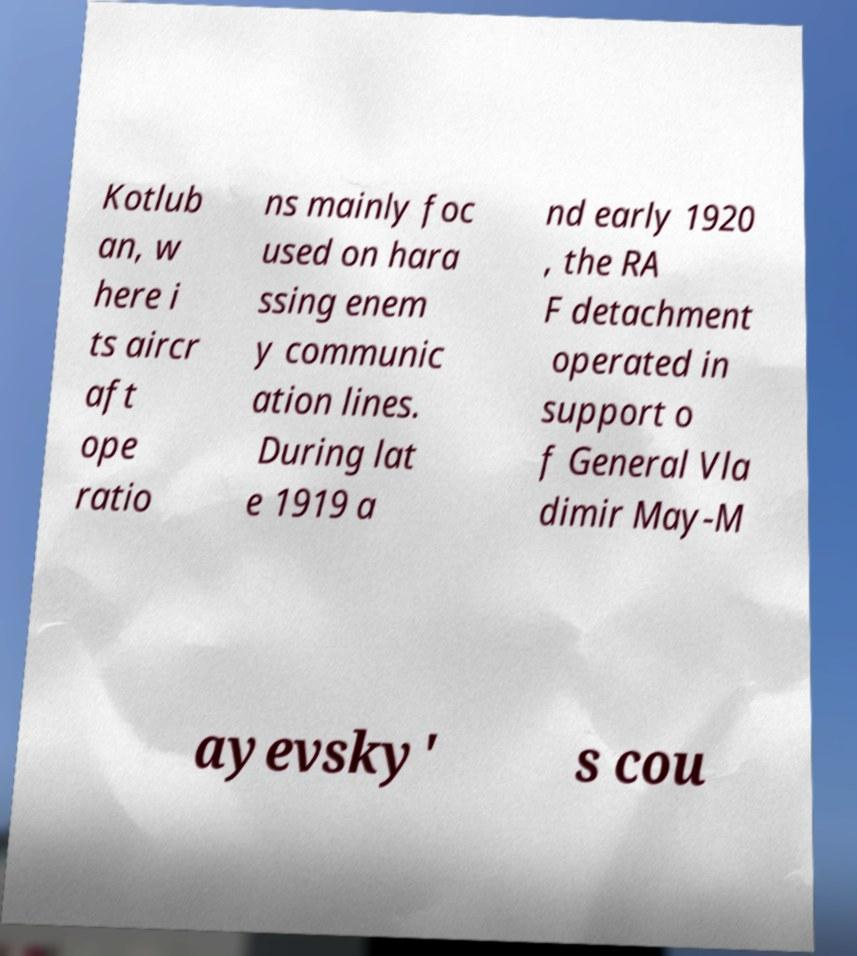Can you accurately transcribe the text from the provided image for me? Kotlub an, w here i ts aircr aft ope ratio ns mainly foc used on hara ssing enem y communic ation lines. During lat e 1919 a nd early 1920 , the RA F detachment operated in support o f General Vla dimir May-M ayevsky' s cou 